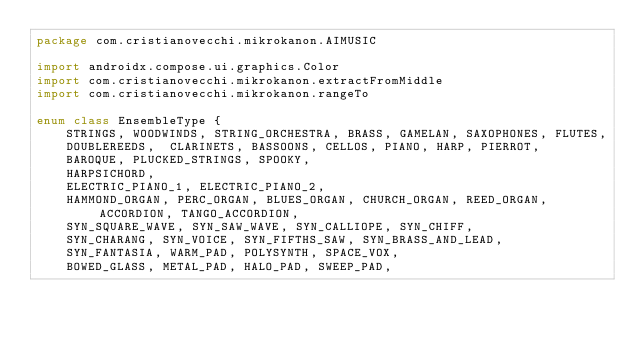Convert code to text. <code><loc_0><loc_0><loc_500><loc_500><_Kotlin_>package com.cristianovecchi.mikrokanon.AIMUSIC

import androidx.compose.ui.graphics.Color
import com.cristianovecchi.mikrokanon.extractFromMiddle
import com.cristianovecchi.mikrokanon.rangeTo

enum class EnsembleType {
    STRINGS, WOODWINDS, STRING_ORCHESTRA, BRASS, GAMELAN, SAXOPHONES, FLUTES,
    DOUBLEREEDS,  CLARINETS, BASSOONS, CELLOS, PIANO, HARP, PIERROT,
    BAROQUE, PLUCKED_STRINGS, SPOOKY,
    HARPSICHORD,
    ELECTRIC_PIANO_1, ELECTRIC_PIANO_2,
    HAMMOND_ORGAN, PERC_ORGAN, BLUES_ORGAN, CHURCH_ORGAN, REED_ORGAN, ACCORDION, TANGO_ACCORDION,
    SYN_SQUARE_WAVE, SYN_SAW_WAVE, SYN_CALLIOPE, SYN_CHIFF,
    SYN_CHARANG, SYN_VOICE, SYN_FIFTHS_SAW, SYN_BRASS_AND_LEAD,
    SYN_FANTASIA, WARM_PAD, POLYSYNTH, SPACE_VOX,
    BOWED_GLASS, METAL_PAD, HALO_PAD, SWEEP_PAD,</code> 